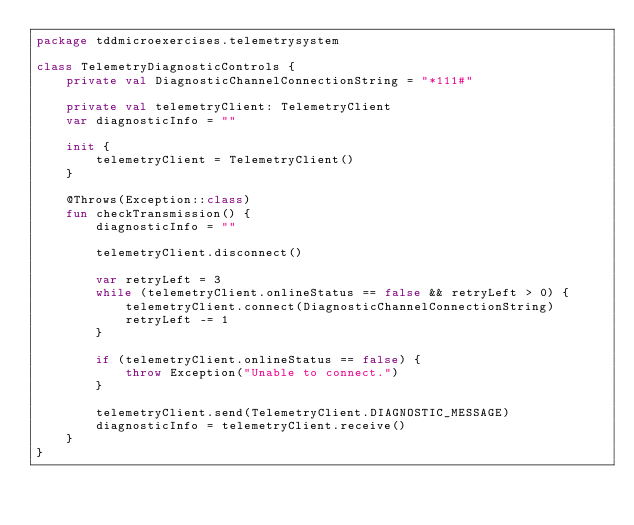<code> <loc_0><loc_0><loc_500><loc_500><_Kotlin_>package tddmicroexercises.telemetrysystem

class TelemetryDiagnosticControls {
    private val DiagnosticChannelConnectionString = "*111#"

    private val telemetryClient: TelemetryClient
    var diagnosticInfo = ""

    init {
        telemetryClient = TelemetryClient()
    }

    @Throws(Exception::class)
    fun checkTransmission() {
        diagnosticInfo = ""

        telemetryClient.disconnect()

        var retryLeft = 3
        while (telemetryClient.onlineStatus == false && retryLeft > 0) {
            telemetryClient.connect(DiagnosticChannelConnectionString)
            retryLeft -= 1
        }

        if (telemetryClient.onlineStatus == false) {
            throw Exception("Unable to connect.")
        }

        telemetryClient.send(TelemetryClient.DIAGNOSTIC_MESSAGE)
        diagnosticInfo = telemetryClient.receive()
    }
}
</code> 